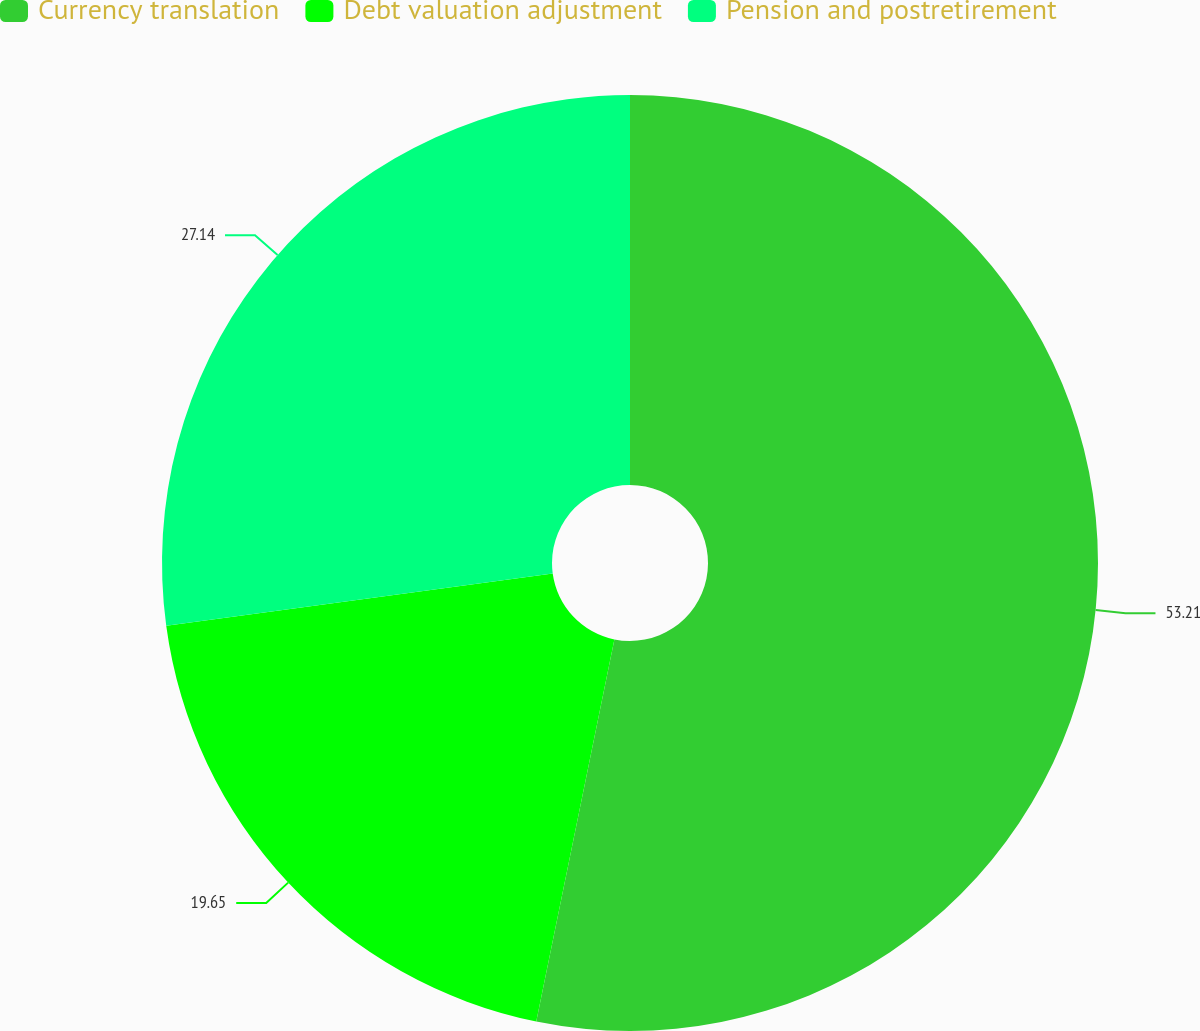Convert chart to OTSL. <chart><loc_0><loc_0><loc_500><loc_500><pie_chart><fcel>Currency translation<fcel>Debt valuation adjustment<fcel>Pension and postretirement<nl><fcel>53.21%<fcel>19.65%<fcel>27.14%<nl></chart> 